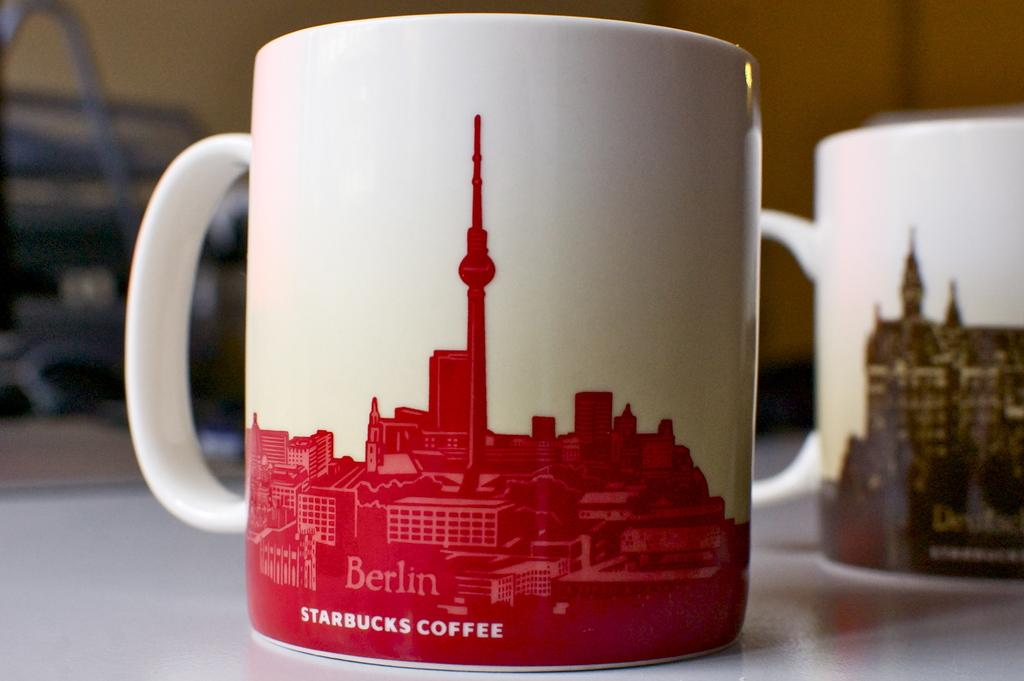Provide a one-sentence caption for the provided image. Two coffee mugs, one from Starbucks, sit on a tabletop. 